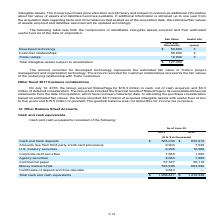According to Atlassian Plc's financial document, What does the amount recorded for developed technology represent? The estimated fair value of Trello’s project management and organization technology. The document states: "ount recorded for developed technology represents the estimated fair value of Trello’s project management and organization technology. The amount reco..." Also, What does the amount recorded for customer relationships represent? The fair values of the underlying relationship with Trello customers. The document states: "nt recorded for customer relationships represents the fair values of the underlying relationship with Trello customers...." Also, What is the useful life (in years) of developed technology? According to the financial document, 3. The relevant text states: "Developed technology $ 50,600 3..." Also, can you calculate: What is the difference in fair value between developed technology and customer relationships? Based on the calculation: 56,900-50,600, the result is 6300 (in thousands). This is based on the information: "Customer relationships 56,900 2 Developed technology $ 50,600 3..." The key data points involved are: 50,600, 56,900. Additionally, What are the intangible assets that have a fair value of above $20,000 thousands? The document shows two values: Developed technology and Customer relationships. From the document: "Developed technology $ 50,600 3 Customer relationships 56,900 2..." Also, can you calculate: What is the percentage constitution of trade names among the total intangible assets subject to amortization? Based on the calculation: 19,900/127,400, the result is 15.62 (percentage). This is based on the information: "Trade names 19,900 3 Total intangible assets subject to amortization $ 127,400..." The key data points involved are: 127,400, 19,900. 